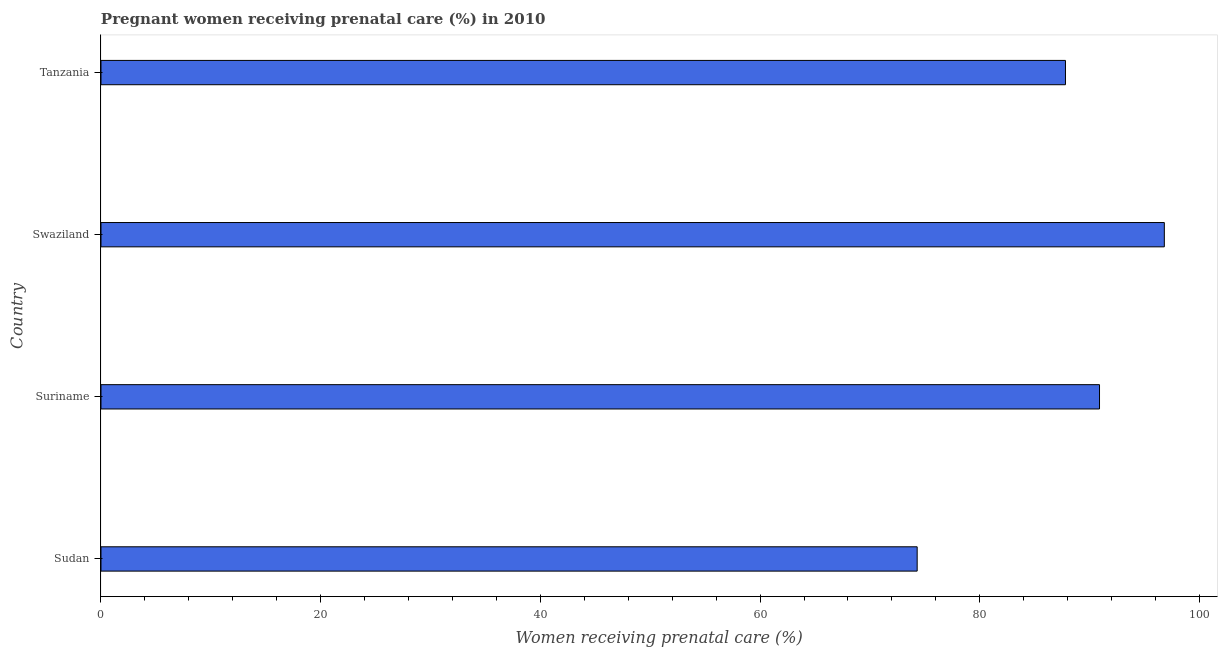Does the graph contain any zero values?
Give a very brief answer. No. What is the title of the graph?
Make the answer very short. Pregnant women receiving prenatal care (%) in 2010. What is the label or title of the X-axis?
Ensure brevity in your answer.  Women receiving prenatal care (%). What is the label or title of the Y-axis?
Provide a succinct answer. Country. What is the percentage of pregnant women receiving prenatal care in Suriname?
Make the answer very short. 90.9. Across all countries, what is the maximum percentage of pregnant women receiving prenatal care?
Give a very brief answer. 96.8. Across all countries, what is the minimum percentage of pregnant women receiving prenatal care?
Make the answer very short. 74.3. In which country was the percentage of pregnant women receiving prenatal care maximum?
Your answer should be very brief. Swaziland. In which country was the percentage of pregnant women receiving prenatal care minimum?
Make the answer very short. Sudan. What is the sum of the percentage of pregnant women receiving prenatal care?
Provide a short and direct response. 349.8. What is the difference between the percentage of pregnant women receiving prenatal care in Swaziland and Tanzania?
Give a very brief answer. 9. What is the average percentage of pregnant women receiving prenatal care per country?
Offer a very short reply. 87.45. What is the median percentage of pregnant women receiving prenatal care?
Provide a succinct answer. 89.35. What is the ratio of the percentage of pregnant women receiving prenatal care in Sudan to that in Suriname?
Offer a terse response. 0.82. Is the sum of the percentage of pregnant women receiving prenatal care in Sudan and Suriname greater than the maximum percentage of pregnant women receiving prenatal care across all countries?
Ensure brevity in your answer.  Yes. In how many countries, is the percentage of pregnant women receiving prenatal care greater than the average percentage of pregnant women receiving prenatal care taken over all countries?
Give a very brief answer. 3. Are all the bars in the graph horizontal?
Ensure brevity in your answer.  Yes. How many countries are there in the graph?
Make the answer very short. 4. What is the Women receiving prenatal care (%) of Sudan?
Provide a short and direct response. 74.3. What is the Women receiving prenatal care (%) in Suriname?
Ensure brevity in your answer.  90.9. What is the Women receiving prenatal care (%) in Swaziland?
Keep it short and to the point. 96.8. What is the Women receiving prenatal care (%) in Tanzania?
Provide a short and direct response. 87.8. What is the difference between the Women receiving prenatal care (%) in Sudan and Suriname?
Provide a succinct answer. -16.6. What is the difference between the Women receiving prenatal care (%) in Sudan and Swaziland?
Make the answer very short. -22.5. What is the difference between the Women receiving prenatal care (%) in Sudan and Tanzania?
Keep it short and to the point. -13.5. What is the difference between the Women receiving prenatal care (%) in Suriname and Swaziland?
Give a very brief answer. -5.9. What is the difference between the Women receiving prenatal care (%) in Suriname and Tanzania?
Ensure brevity in your answer.  3.1. What is the ratio of the Women receiving prenatal care (%) in Sudan to that in Suriname?
Offer a terse response. 0.82. What is the ratio of the Women receiving prenatal care (%) in Sudan to that in Swaziland?
Your answer should be compact. 0.77. What is the ratio of the Women receiving prenatal care (%) in Sudan to that in Tanzania?
Give a very brief answer. 0.85. What is the ratio of the Women receiving prenatal care (%) in Suriname to that in Swaziland?
Ensure brevity in your answer.  0.94. What is the ratio of the Women receiving prenatal care (%) in Suriname to that in Tanzania?
Your response must be concise. 1.03. What is the ratio of the Women receiving prenatal care (%) in Swaziland to that in Tanzania?
Your response must be concise. 1.1. 